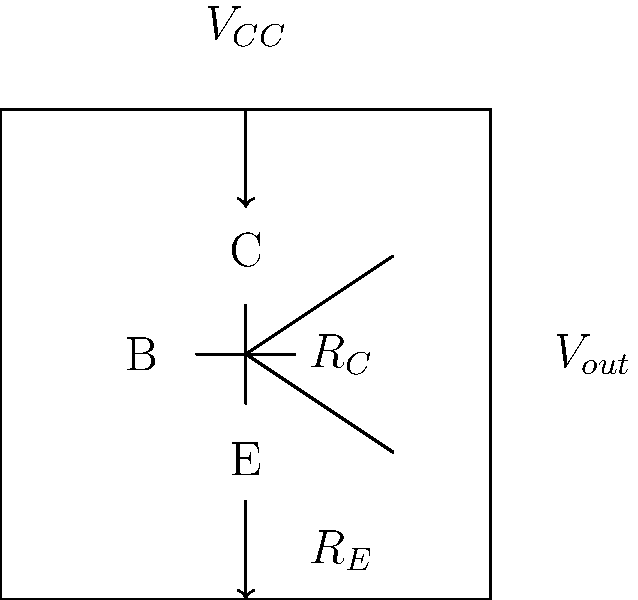Design a common-emitter amplifier circuit using an NPN transistor with the following specifications:
- Supply voltage $V_{CC} = 12\text{ V}$
- Collector current $I_C = 2\text{ mA}$
- Voltage gain $A_v = 100$
- Emitter resistance $R_E = 100\text{ Ω}$

Calculate the required collector resistance $R_C$ and the resulting output voltage swing. To solve this problem, we'll follow these steps:

1) First, calculate the AC emitter resistance $r_e'$:
   $r_e' = \frac{25\text{ mV}}{I_C} = \frac{25\text{ mV}}{2\text{ mA}} = 12.5\text{ Ω}$

2) The voltage gain $A_v$ is given by:
   $A_v = -\frac{R_C}{r_e' + R_E}$

3) Rearrange to solve for $R_C$:
   $R_C = |A_v| \cdot (r_e' + R_E) = 100 \cdot (12.5\text{ Ω} + 100\text{ Ω}) = 11,250\text{ Ω}$

4) Round $R_C$ to the nearest standard value: $11\text{ kΩ}$

5) Calculate the DC voltage drop across $R_C$:
   $V_{RC} = I_C \cdot R_C = 2\text{ mA} \cdot 11\text{ kΩ} = 22\text{ V}$

6) The maximum positive output swing is limited by $V_{CC}$:
   $V_{out(max)} = V_{CC} = 12\text{ V}$

7) The maximum negative output swing is:
   $V_{out(min)} = V_{CC} - V_{RC} = 12\text{ V} - 22\text{ V} = -10\text{ V}$

8) The total output voltage swing is:
   $V_{swing} = V_{out(max)} - V_{out(min)} = 12\text{ V} - (-10\text{ V}) = 22\text{ V}$
Answer: $R_C = 11\text{ kΩ}$, $V_{swing} = 22\text{ V}$ 